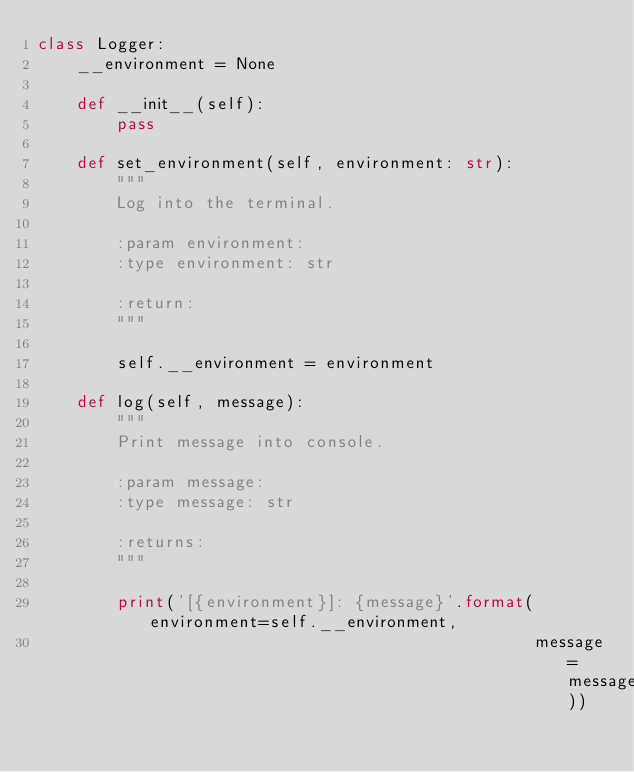<code> <loc_0><loc_0><loc_500><loc_500><_Python_>class Logger:
    __environment = None

    def __init__(self):
        pass

    def set_environment(self, environment: str):
        """
        Log into the terminal.

        :param environment:
        :type environment: str

        :return:
        """

        self.__environment = environment

    def log(self, message):
        """
        Print message into console.

        :param message:
        :type message: str

        :returns:
        """

        print('[{environment}]: {message}'.format(environment=self.__environment,
                                                  message=message))
</code> 